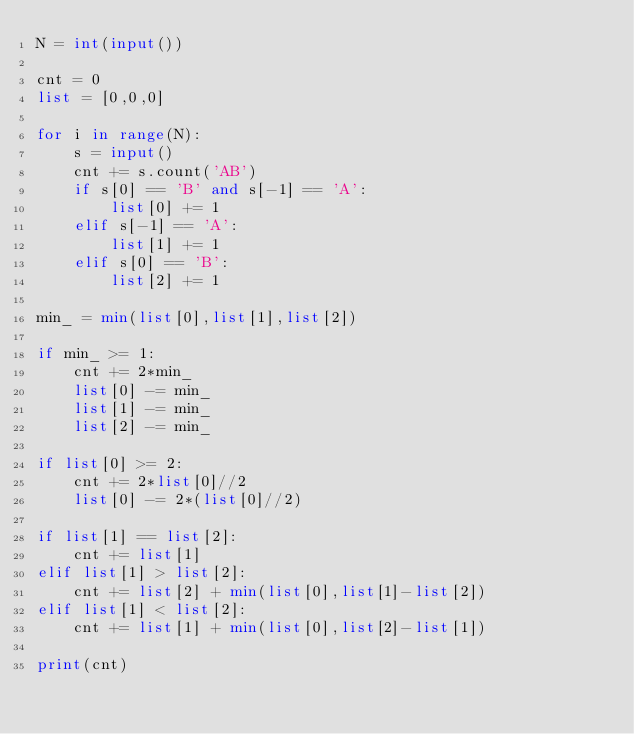Convert code to text. <code><loc_0><loc_0><loc_500><loc_500><_Python_>N = int(input())
 
cnt = 0
list = [0,0,0]
 
for i in range(N):
    s = input()
    cnt += s.count('AB')
    if s[0] == 'B' and s[-1] == 'A':
        list[0] += 1
    elif s[-1] == 'A':
        list[1] += 1
    elif s[0] == 'B':
        list[2] += 1
 
min_ = min(list[0],list[1],list[2])
 
if min_ >= 1:
    cnt += 2*min_
    list[0] -= min_
    list[1] -= min_
    list[2] -= min_
 
if list[0] >= 2:
    cnt += 2*list[0]//2
    list[0] -= 2*(list[0]//2)
 
if list[1] == list[2]:
    cnt += list[1]
elif list[1] > list[2]:
    cnt += list[2] + min(list[0],list[1]-list[2])
elif list[1] < list[2]:
    cnt += list[1] + min(list[0],list[2]-list[1])
 
print(cnt)</code> 